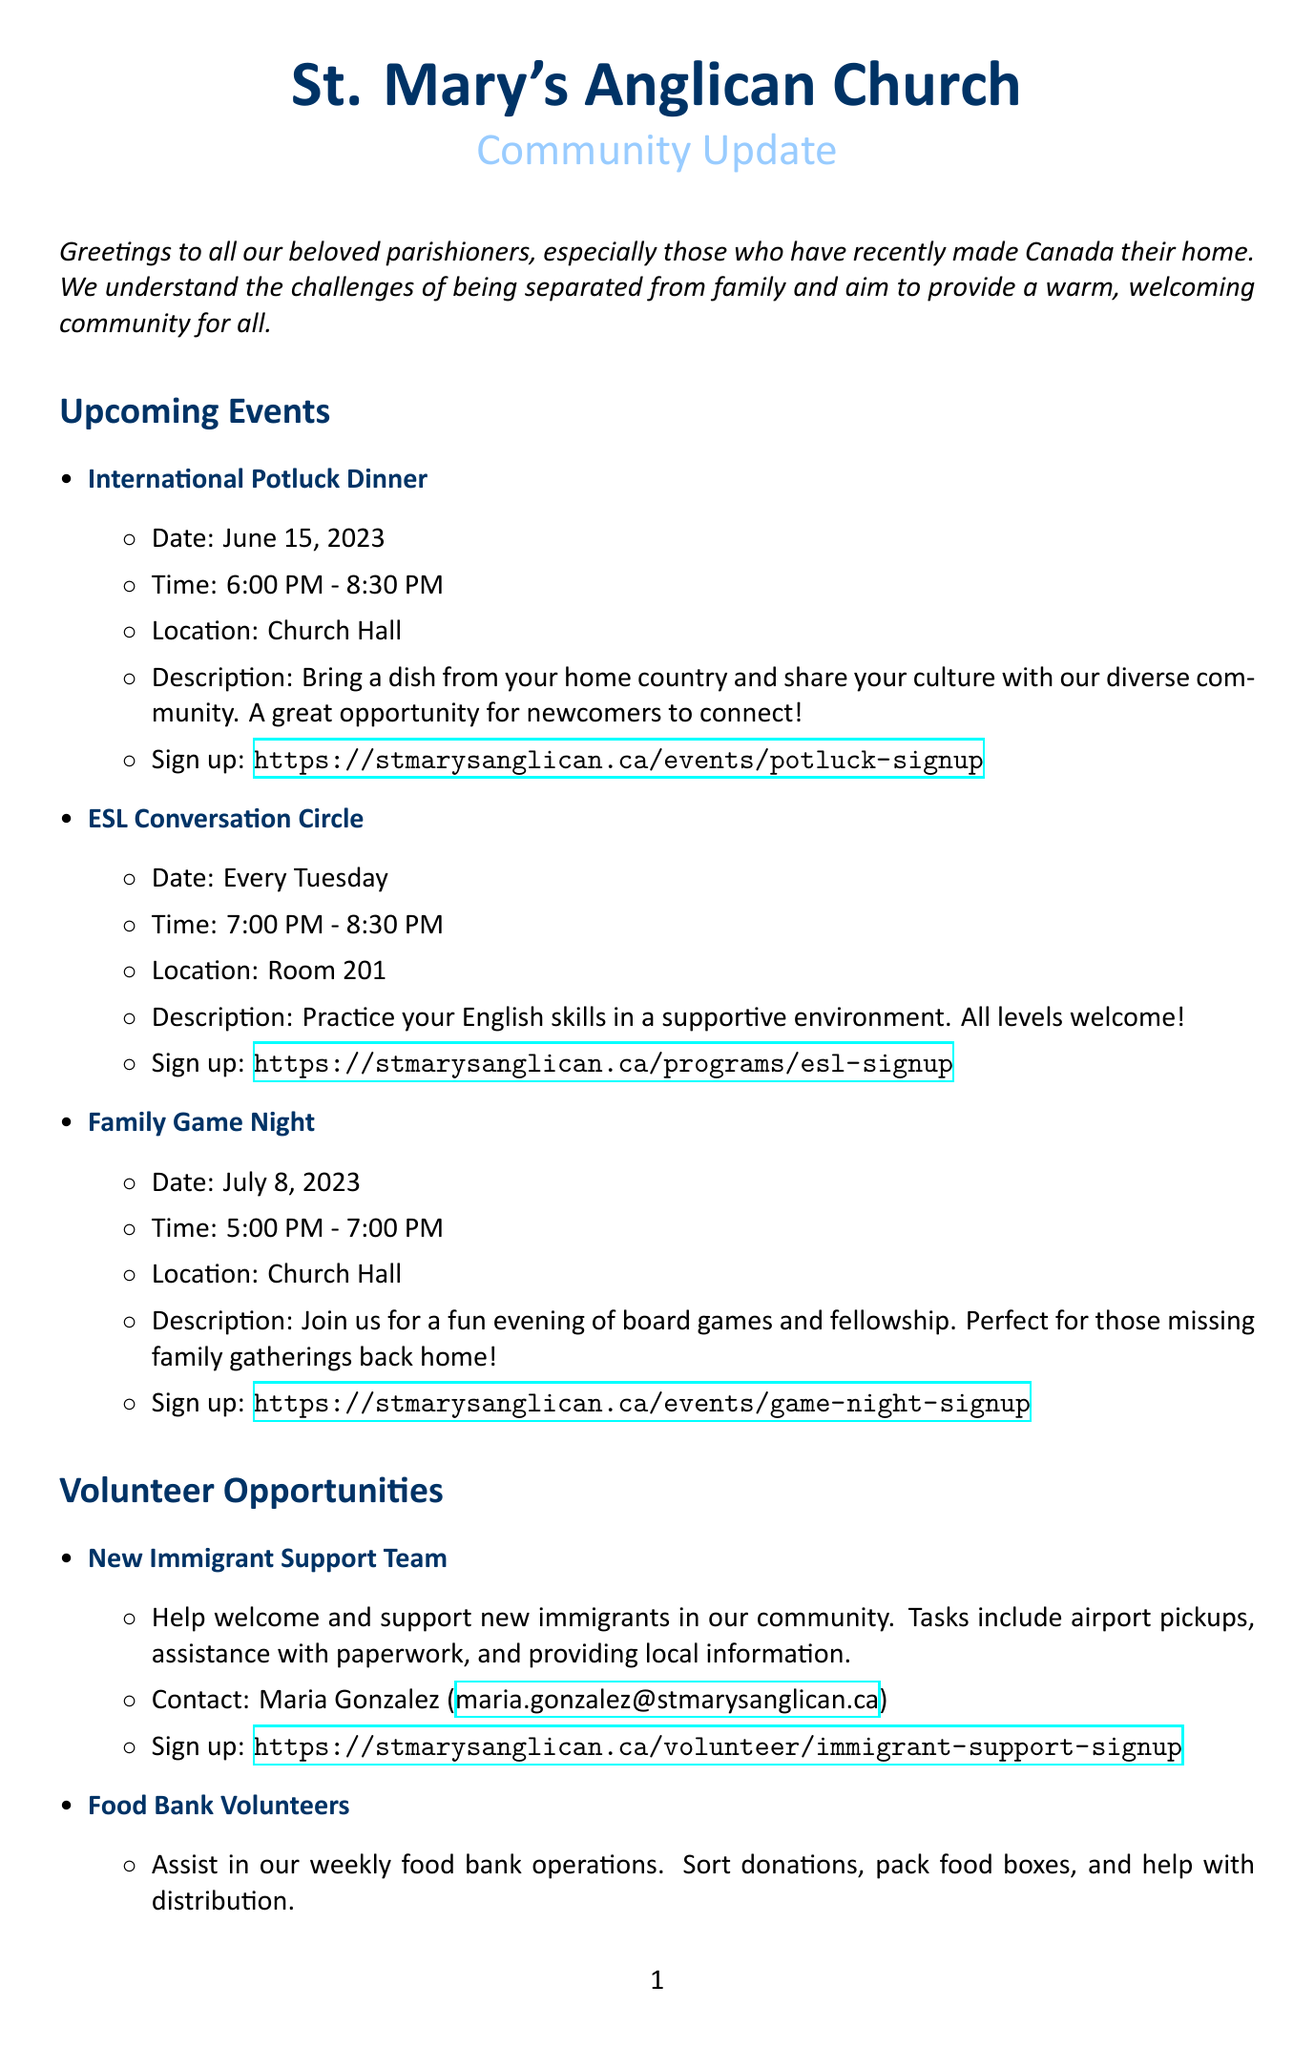What is the date of the International Potluck Dinner? The date is specified in the upcoming events section of the document.
Answer: June 15, 2023 What time does the ESL Conversation Circle start? The start time is mentioned in the description of the ESL Conversation Circle event.
Answer: 7:00 PM Who is the contact person for the New Immigrant Support Team? The contact information is provided in the volunteer opportunities section under the New Immigrant Support Team.
Answer: Maria Gonzalez How often does the Family Game Night occur? The occurrence is mentioned in the upcoming events section.
Answer: Once What is the purpose of the 'Home Away From Home' Support Group? The purpose is explained in the special announcement section of the document.
Answer: Support for those separated from family What resources are provided for newcomers to Canada? The document lists multiple community resources under the Community Resources section.
Answer: Settlement Services, Canadian Immigrant, Newcomer Kitchen What day of the week does the ESL Conversation Circle take place? The day is mentioned in the upcoming events section concerning the ESL Conversation Circle.
Answer: Tuesday How long is the commitment for Virtual Prayer Partners? The commitment duration is stated in the description for Virtual Prayer Partners.
Answer: 30 minutes per week 